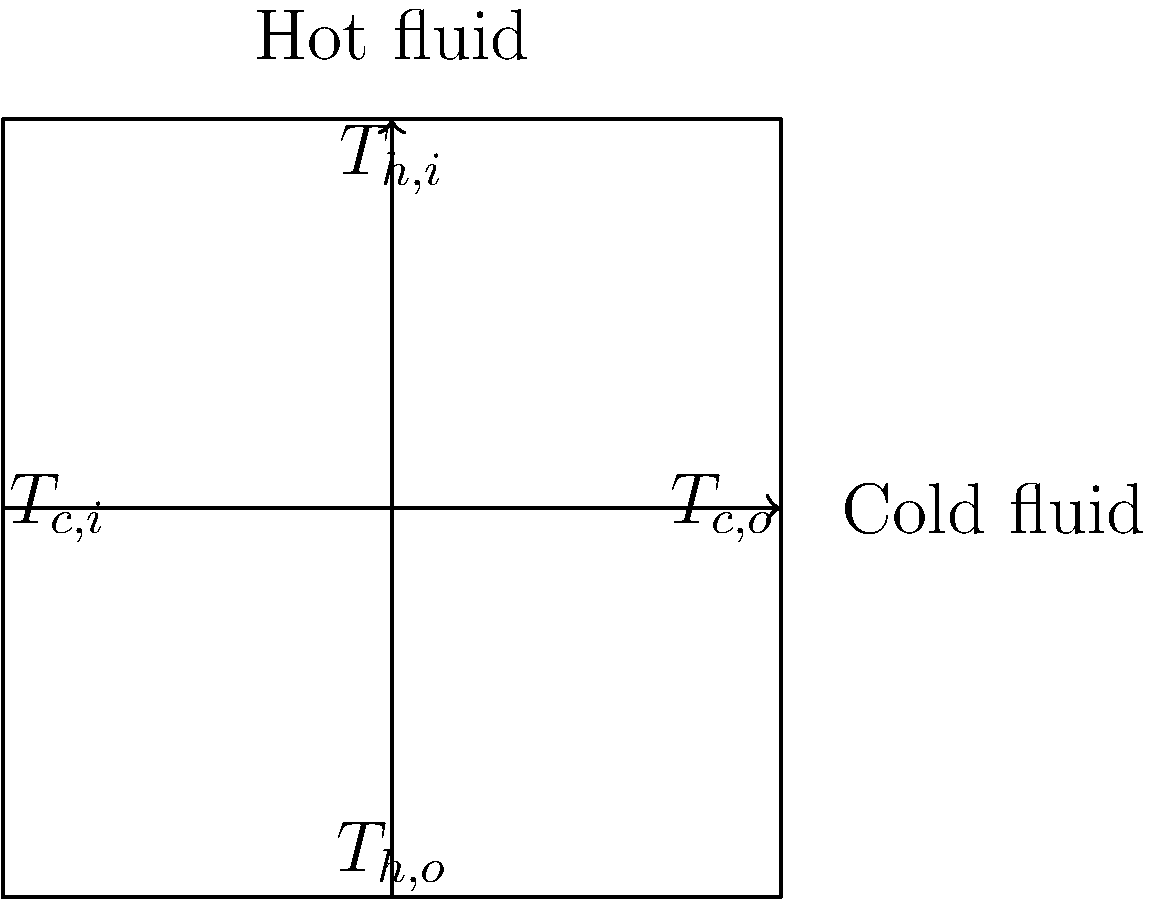In a cross-flow heat exchanger, how does the heat transfer rate compare between parallel flow and counter-flow arrangements, assuming all other parameters remain constant? Consider the implications for overall system efficiency and the potential for heat recovery in an industrial setting. To analyze the heat transfer rates in different flow arrangements, we need to consider several factors:

1. Temperature profiles:
   - In parallel flow, the temperature difference between fluids decreases along the exchanger.
   - In counter-flow, the temperature difference remains more uniform throughout.

2. Log Mean Temperature Difference (LMTD):
   The LMTD for counter-flow is generally higher than for parallel flow, given by:
   $$ LMTD = \frac{\Delta T_1 - \Delta T_2}{\ln(\frac{\Delta T_1}{\Delta T_2})} $$
   Where $\Delta T_1$ and $\Delta T_2$ are temperature differences at each end.

3. Heat transfer rate equation:
   $$ Q = U A (LMTD) $$
   Where $Q$ is heat transfer rate, $U$ is overall heat transfer coefficient, and $A$ is heat transfer area.

4. Efficiency considerations:
   - Counter-flow typically allows for higher heat recovery and can achieve closer approach temperatures.
   - This leads to better utilization of available temperature difference and higher thermodynamic efficiency.

5. Industrial implications:
   - Higher efficiency in counter-flow arrangements can lead to energy savings and reduced operating costs.
   - This aligns with socialist principles of resource optimization and sustainable industrial practices.

6. Marxist economic perspective:
   - Improved heat recovery contributes to reduced waste and more efficient use of resources.
   - This efficiency can be seen as a step towards more equitable distribution of energy resources in society.

Given these factors, counter-flow arrangements generally provide higher heat transfer rates and better overall system efficiency compared to parallel flow, assuming all other parameters remain constant.
Answer: Counter-flow arrangement provides higher heat transfer rate and efficiency. 